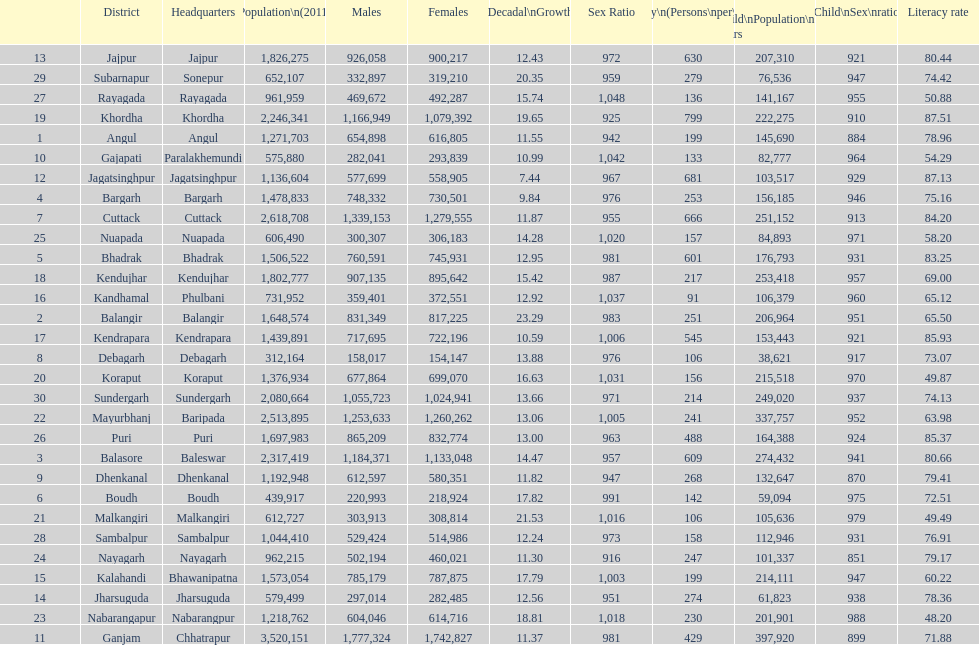Tell me a district that did not have a population over 600,000. Boudh. 